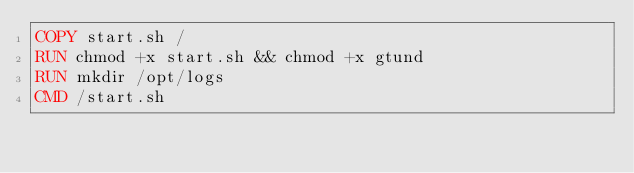Convert code to text. <code><loc_0><loc_0><loc_500><loc_500><_Dockerfile_>COPY start.sh /
RUN chmod +x start.sh && chmod +x gtund
RUN mkdir /opt/logs
CMD /start.sh</code> 